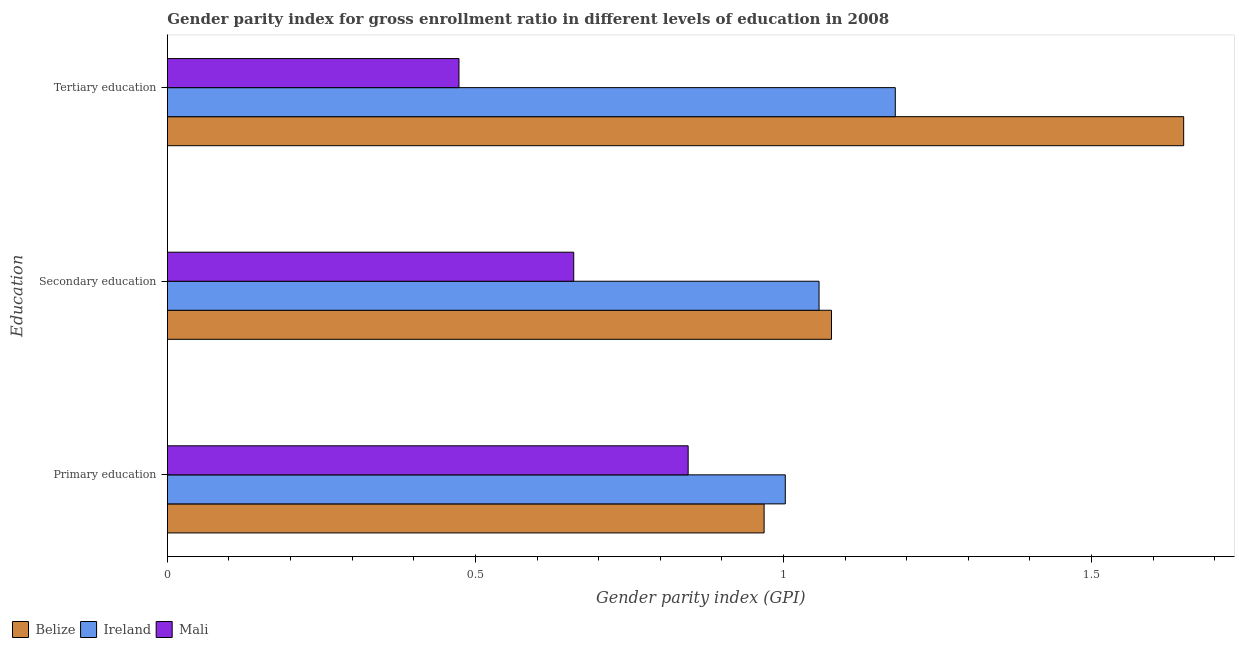How many groups of bars are there?
Provide a succinct answer. 3. Are the number of bars on each tick of the Y-axis equal?
Give a very brief answer. Yes. How many bars are there on the 2nd tick from the bottom?
Your answer should be compact. 3. What is the gender parity index in tertiary education in Ireland?
Offer a terse response. 1.18. Across all countries, what is the maximum gender parity index in tertiary education?
Your response must be concise. 1.65. Across all countries, what is the minimum gender parity index in primary education?
Give a very brief answer. 0.85. In which country was the gender parity index in tertiary education maximum?
Your answer should be very brief. Belize. In which country was the gender parity index in secondary education minimum?
Offer a terse response. Mali. What is the total gender parity index in primary education in the graph?
Offer a very short reply. 2.82. What is the difference between the gender parity index in tertiary education in Ireland and that in Mali?
Provide a succinct answer. 0.71. What is the difference between the gender parity index in tertiary education in Belize and the gender parity index in primary education in Mali?
Keep it short and to the point. 0.8. What is the average gender parity index in primary education per country?
Your answer should be compact. 0.94. What is the difference between the gender parity index in primary education and gender parity index in secondary education in Mali?
Offer a terse response. 0.19. In how many countries, is the gender parity index in tertiary education greater than 0.4 ?
Give a very brief answer. 3. What is the ratio of the gender parity index in tertiary education in Ireland to that in Mali?
Provide a short and direct response. 2.5. Is the gender parity index in tertiary education in Ireland less than that in Mali?
Keep it short and to the point. No. What is the difference between the highest and the second highest gender parity index in primary education?
Your answer should be very brief. 0.03. What is the difference between the highest and the lowest gender parity index in tertiary education?
Give a very brief answer. 1.18. In how many countries, is the gender parity index in primary education greater than the average gender parity index in primary education taken over all countries?
Your answer should be very brief. 2. Is the sum of the gender parity index in tertiary education in Mali and Ireland greater than the maximum gender parity index in primary education across all countries?
Your answer should be compact. Yes. What does the 1st bar from the top in Tertiary education represents?
Your response must be concise. Mali. What does the 1st bar from the bottom in Secondary education represents?
Your answer should be compact. Belize. How many bars are there?
Your answer should be very brief. 9. Are all the bars in the graph horizontal?
Provide a succinct answer. Yes. Are the values on the major ticks of X-axis written in scientific E-notation?
Give a very brief answer. No. Does the graph contain any zero values?
Offer a very short reply. No. How many legend labels are there?
Offer a very short reply. 3. How are the legend labels stacked?
Your answer should be very brief. Horizontal. What is the title of the graph?
Make the answer very short. Gender parity index for gross enrollment ratio in different levels of education in 2008. Does "Cambodia" appear as one of the legend labels in the graph?
Your answer should be very brief. No. What is the label or title of the X-axis?
Ensure brevity in your answer.  Gender parity index (GPI). What is the label or title of the Y-axis?
Offer a terse response. Education. What is the Gender parity index (GPI) of Belize in Primary education?
Your answer should be very brief. 0.97. What is the Gender parity index (GPI) in Ireland in Primary education?
Provide a short and direct response. 1. What is the Gender parity index (GPI) in Mali in Primary education?
Your answer should be very brief. 0.85. What is the Gender parity index (GPI) of Belize in Secondary education?
Your response must be concise. 1.08. What is the Gender parity index (GPI) in Ireland in Secondary education?
Provide a succinct answer. 1.06. What is the Gender parity index (GPI) of Mali in Secondary education?
Keep it short and to the point. 0.66. What is the Gender parity index (GPI) in Belize in Tertiary education?
Your answer should be very brief. 1.65. What is the Gender parity index (GPI) of Ireland in Tertiary education?
Your answer should be very brief. 1.18. What is the Gender parity index (GPI) in Mali in Tertiary education?
Ensure brevity in your answer.  0.47. Across all Education, what is the maximum Gender parity index (GPI) in Belize?
Offer a very short reply. 1.65. Across all Education, what is the maximum Gender parity index (GPI) in Ireland?
Provide a succinct answer. 1.18. Across all Education, what is the maximum Gender parity index (GPI) in Mali?
Your answer should be compact. 0.85. Across all Education, what is the minimum Gender parity index (GPI) of Belize?
Give a very brief answer. 0.97. Across all Education, what is the minimum Gender parity index (GPI) in Ireland?
Keep it short and to the point. 1. Across all Education, what is the minimum Gender parity index (GPI) in Mali?
Your response must be concise. 0.47. What is the total Gender parity index (GPI) in Belize in the graph?
Keep it short and to the point. 3.7. What is the total Gender parity index (GPI) of Ireland in the graph?
Give a very brief answer. 3.24. What is the total Gender parity index (GPI) of Mali in the graph?
Your answer should be compact. 1.98. What is the difference between the Gender parity index (GPI) in Belize in Primary education and that in Secondary education?
Your answer should be compact. -0.11. What is the difference between the Gender parity index (GPI) in Ireland in Primary education and that in Secondary education?
Keep it short and to the point. -0.05. What is the difference between the Gender parity index (GPI) of Mali in Primary education and that in Secondary education?
Make the answer very short. 0.19. What is the difference between the Gender parity index (GPI) in Belize in Primary education and that in Tertiary education?
Offer a very short reply. -0.68. What is the difference between the Gender parity index (GPI) of Ireland in Primary education and that in Tertiary education?
Ensure brevity in your answer.  -0.18. What is the difference between the Gender parity index (GPI) in Mali in Primary education and that in Tertiary education?
Offer a very short reply. 0.37. What is the difference between the Gender parity index (GPI) in Belize in Secondary education and that in Tertiary education?
Your response must be concise. -0.57. What is the difference between the Gender parity index (GPI) of Ireland in Secondary education and that in Tertiary education?
Keep it short and to the point. -0.12. What is the difference between the Gender parity index (GPI) of Mali in Secondary education and that in Tertiary education?
Your response must be concise. 0.19. What is the difference between the Gender parity index (GPI) in Belize in Primary education and the Gender parity index (GPI) in Ireland in Secondary education?
Provide a succinct answer. -0.09. What is the difference between the Gender parity index (GPI) of Belize in Primary education and the Gender parity index (GPI) of Mali in Secondary education?
Keep it short and to the point. 0.31. What is the difference between the Gender parity index (GPI) of Ireland in Primary education and the Gender parity index (GPI) of Mali in Secondary education?
Offer a very short reply. 0.34. What is the difference between the Gender parity index (GPI) in Belize in Primary education and the Gender parity index (GPI) in Ireland in Tertiary education?
Your response must be concise. -0.21. What is the difference between the Gender parity index (GPI) of Belize in Primary education and the Gender parity index (GPI) of Mali in Tertiary education?
Ensure brevity in your answer.  0.5. What is the difference between the Gender parity index (GPI) of Ireland in Primary education and the Gender parity index (GPI) of Mali in Tertiary education?
Ensure brevity in your answer.  0.53. What is the difference between the Gender parity index (GPI) in Belize in Secondary education and the Gender parity index (GPI) in Ireland in Tertiary education?
Your answer should be very brief. -0.1. What is the difference between the Gender parity index (GPI) of Belize in Secondary education and the Gender parity index (GPI) of Mali in Tertiary education?
Give a very brief answer. 0.6. What is the difference between the Gender parity index (GPI) in Ireland in Secondary education and the Gender parity index (GPI) in Mali in Tertiary education?
Give a very brief answer. 0.58. What is the average Gender parity index (GPI) of Belize per Education?
Your answer should be compact. 1.23. What is the average Gender parity index (GPI) of Ireland per Education?
Make the answer very short. 1.08. What is the average Gender parity index (GPI) of Mali per Education?
Your answer should be compact. 0.66. What is the difference between the Gender parity index (GPI) of Belize and Gender parity index (GPI) of Ireland in Primary education?
Your response must be concise. -0.03. What is the difference between the Gender parity index (GPI) of Belize and Gender parity index (GPI) of Mali in Primary education?
Give a very brief answer. 0.12. What is the difference between the Gender parity index (GPI) of Ireland and Gender parity index (GPI) of Mali in Primary education?
Provide a short and direct response. 0.16. What is the difference between the Gender parity index (GPI) in Belize and Gender parity index (GPI) in Ireland in Secondary education?
Give a very brief answer. 0.02. What is the difference between the Gender parity index (GPI) in Belize and Gender parity index (GPI) in Mali in Secondary education?
Your response must be concise. 0.42. What is the difference between the Gender parity index (GPI) of Ireland and Gender parity index (GPI) of Mali in Secondary education?
Offer a very short reply. 0.4. What is the difference between the Gender parity index (GPI) in Belize and Gender parity index (GPI) in Ireland in Tertiary education?
Make the answer very short. 0.47. What is the difference between the Gender parity index (GPI) in Belize and Gender parity index (GPI) in Mali in Tertiary education?
Offer a terse response. 1.18. What is the difference between the Gender parity index (GPI) of Ireland and Gender parity index (GPI) of Mali in Tertiary education?
Make the answer very short. 0.71. What is the ratio of the Gender parity index (GPI) in Belize in Primary education to that in Secondary education?
Provide a succinct answer. 0.9. What is the ratio of the Gender parity index (GPI) in Ireland in Primary education to that in Secondary education?
Your response must be concise. 0.95. What is the ratio of the Gender parity index (GPI) in Mali in Primary education to that in Secondary education?
Provide a short and direct response. 1.28. What is the ratio of the Gender parity index (GPI) in Belize in Primary education to that in Tertiary education?
Keep it short and to the point. 0.59. What is the ratio of the Gender parity index (GPI) in Ireland in Primary education to that in Tertiary education?
Keep it short and to the point. 0.85. What is the ratio of the Gender parity index (GPI) in Mali in Primary education to that in Tertiary education?
Offer a very short reply. 1.79. What is the ratio of the Gender parity index (GPI) in Belize in Secondary education to that in Tertiary education?
Make the answer very short. 0.65. What is the ratio of the Gender parity index (GPI) in Ireland in Secondary education to that in Tertiary education?
Provide a succinct answer. 0.9. What is the ratio of the Gender parity index (GPI) in Mali in Secondary education to that in Tertiary education?
Your response must be concise. 1.39. What is the difference between the highest and the second highest Gender parity index (GPI) in Belize?
Provide a succinct answer. 0.57. What is the difference between the highest and the second highest Gender parity index (GPI) of Ireland?
Give a very brief answer. 0.12. What is the difference between the highest and the second highest Gender parity index (GPI) of Mali?
Your response must be concise. 0.19. What is the difference between the highest and the lowest Gender parity index (GPI) of Belize?
Give a very brief answer. 0.68. What is the difference between the highest and the lowest Gender parity index (GPI) of Ireland?
Make the answer very short. 0.18. What is the difference between the highest and the lowest Gender parity index (GPI) of Mali?
Ensure brevity in your answer.  0.37. 